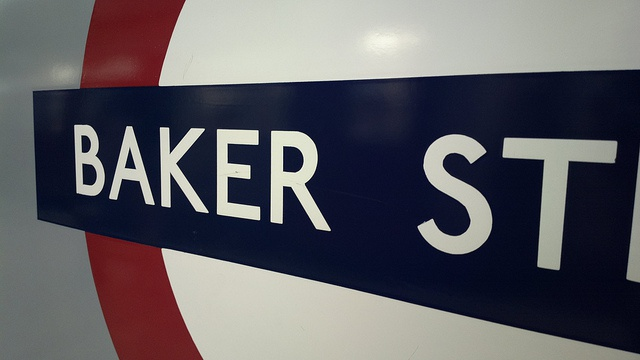Describe the objects in this image and their specific colors. I can see various objects in this image with different colors. 